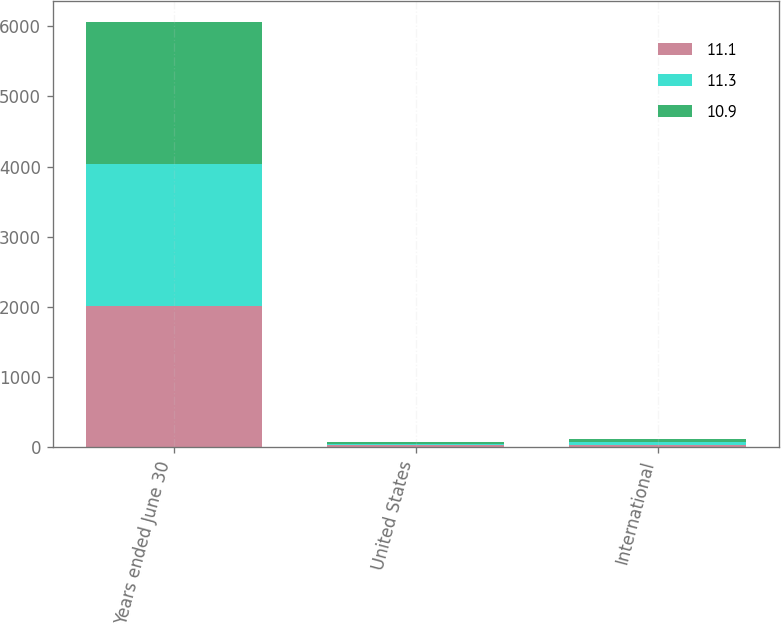Convert chart. <chart><loc_0><loc_0><loc_500><loc_500><stacked_bar_chart><ecel><fcel>Years ended June 30<fcel>United States<fcel>International<nl><fcel>11.1<fcel>2019<fcel>28.6<fcel>39.1<nl><fcel>11.3<fcel>2018<fcel>27.3<fcel>39.5<nl><fcel>10.9<fcel>2017<fcel>27.3<fcel>37.8<nl></chart> 